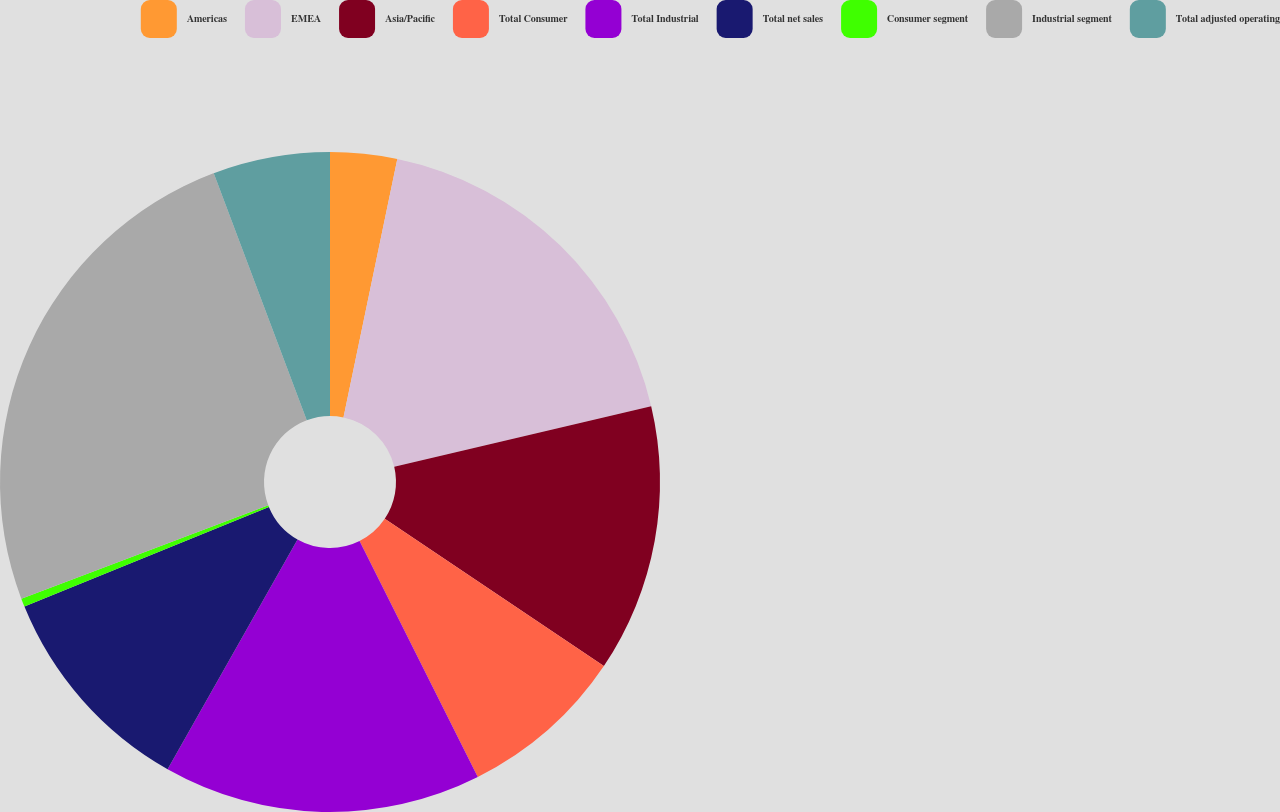Convert chart. <chart><loc_0><loc_0><loc_500><loc_500><pie_chart><fcel>Americas<fcel>EMEA<fcel>Asia/Pacific<fcel>Total Consumer<fcel>Total Industrial<fcel>Total net sales<fcel>Consumer segment<fcel>Industrial segment<fcel>Total adjusted operating<nl><fcel>3.27%<fcel>18.04%<fcel>13.11%<fcel>8.19%<fcel>15.58%<fcel>10.65%<fcel>0.41%<fcel>25.02%<fcel>5.73%<nl></chart> 